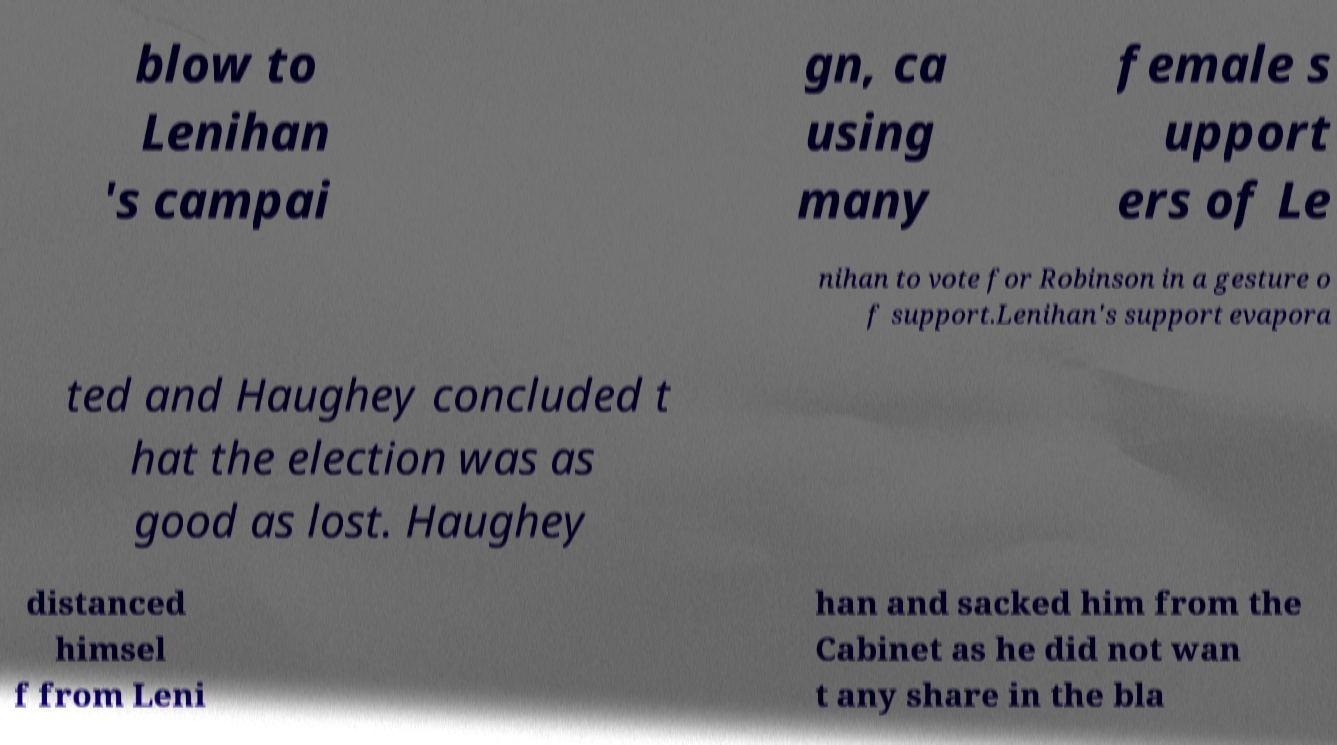Could you assist in decoding the text presented in this image and type it out clearly? blow to Lenihan 's campai gn, ca using many female s upport ers of Le nihan to vote for Robinson in a gesture o f support.Lenihan's support evapora ted and Haughey concluded t hat the election was as good as lost. Haughey distanced himsel f from Leni han and sacked him from the Cabinet as he did not wan t any share in the bla 